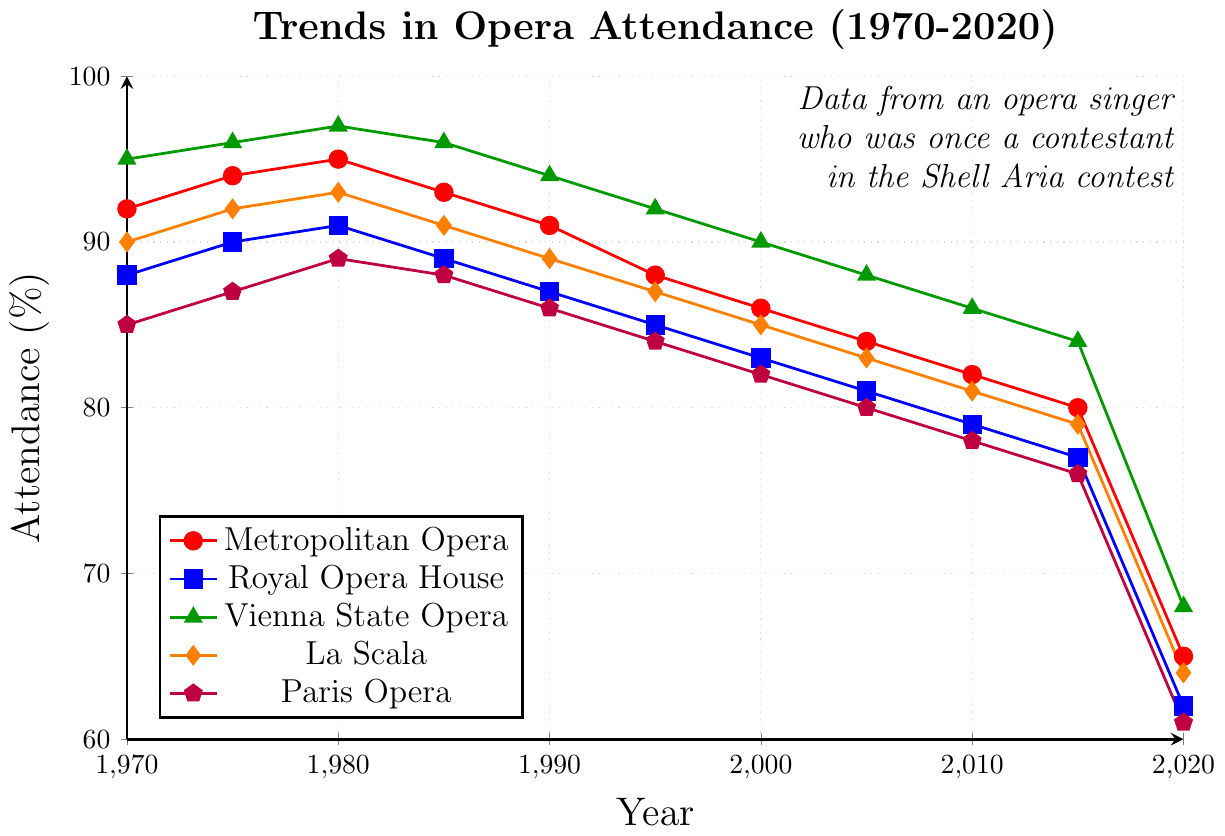What is the trend in attendance for the Metropolitan Opera from 1970 to 2020? We observe the red line representing the Metropolitan Opera, which generally shows a declining trend in attendance over the years. Starting from about 92% in 1970, it peaks at 95% in 1980, and then steadily declines to 65% in 2020.
Answer: Declining Which opera house had the highest attendance in 1980? By examining the attendance levels for 1980, we see that the Vienna State Opera (green) had the highest attendance at 97%.
Answer: Vienna State Opera In 2020, which opera house had the lowest attendance? By looking at the attendance for the year 2020, we see that the Paris Opera (purple) had the lowest attendance at 61%.
Answer: Paris Opera Compare the attendance at the Metropolitan Opera and the Royal Opera House in 2015. Which one had higher attendance? The plot shows that in 2015, the Metropolitan Opera (red) had an attendance of 80%, whereas the Royal Opera House (blue) had an attendance of 77%. Therefore, the Metropolitan Opera had higher attendance.
Answer: Metropolitan Opera What is the difference in attendance between La Scala and the Paris Opera in 1975? In 1975, La Scala (orange) had an attendance of 92% and the Paris Opera (purple) had an attendance of 87%. The difference is 92% - 87% = 5%.
Answer: 5% Identify any year where La Scala and the Paris Opera had the same attendance rates. By inspecting the graph, we notice that in the year 1985, both La Scala (orange) and the Paris Opera (purple) had attendance rates of 88%.
Answer: 1985 Calculate the average attendance rate for the Vienna State Opera from 1970 to 2020. The attendance rates for the Vienna State Opera across the years are 95, 96, 97, 96, 94, 92, 90, 88, 86, 84, 68. Summing these values gives 986. Dividing by the number of years (11) results in approximately 89.64%.
Answer: 89.64% Between 1970 and 2000, which opera house experienced the largest drop in attendance? By analyzing the chart, we see that the Metropolitan Opera (red) dropped from 92% to 86%, the Royal Opera House (blue) dropped from 88% to 83%, the Vienna State Opera (green) went from 95% to 90%, La Scala (orange) dropped from 90% to 85%, and the Paris Opera (purple) dropped from 85% to 82%. The biggest drop is for the Metropolitan Opera with a 6% decrease.
Answer: Metropolitan Opera What was the attendance trend for the Royal Opera House from 2000 to 2020? The blue line representing the Royal Opera House shows a downward trend, starting from 83% in 2000 to 62% in 2020. This indicates a consistent decline in attendance over these years.
Answer: Declining Was there any year when the attendance rate for all opera houses was above 90%? By scanning the plot, only the years 1970, 1975, and 1980 show attendance rates above 90% for some opera houses but not for all, as Paris Opera always remains below 90%. Thus, there was no year when all opera houses had attendance rates above 90%.
Answer: No 